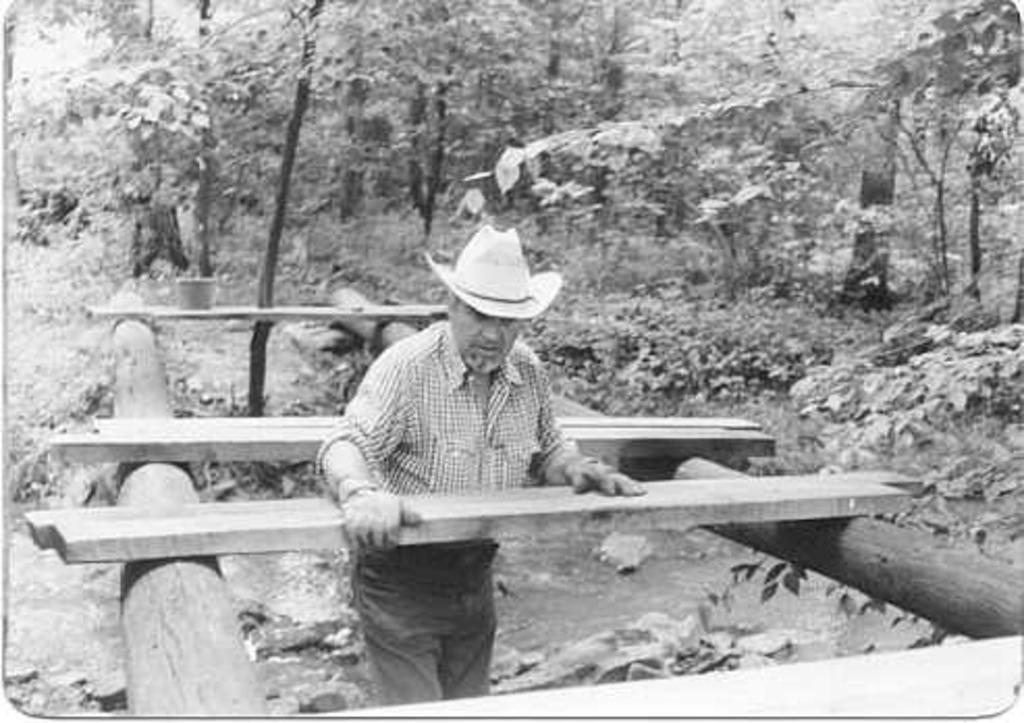In one or two sentences, can you explain what this image depicts? In this image I can see a man and I can see he is wearing a hat, shirt, pants and gloves. I can also see few woods, number of trees and I can see this image is black and white in colour. 